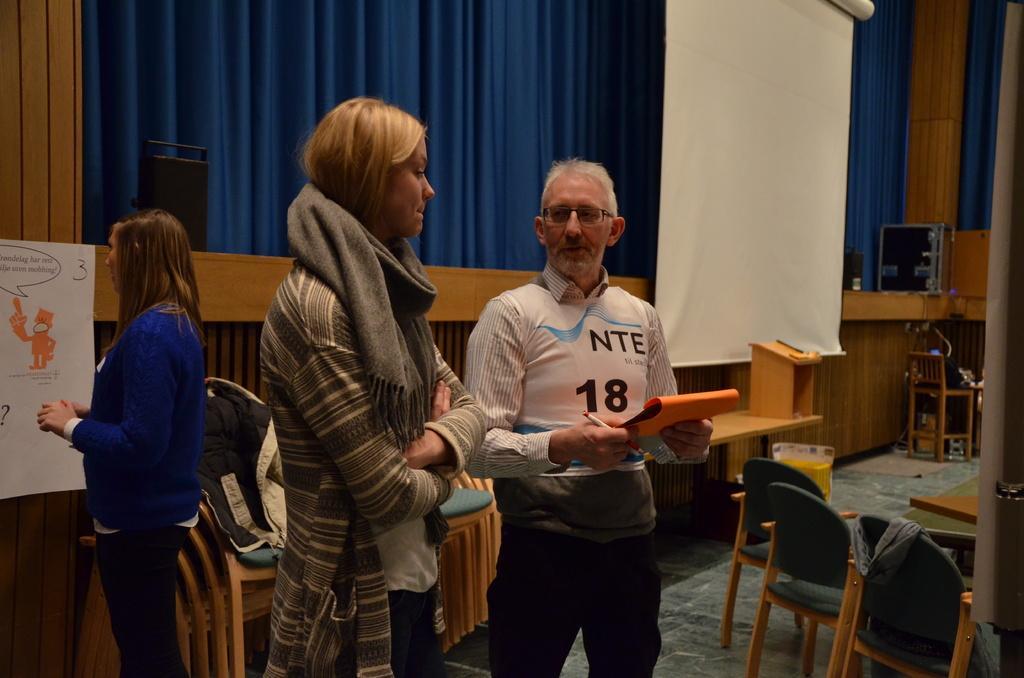Could you give a brief overview of what you see in this image? In picture there are two women and man a man and women are talking to each other in the room there are many chairs with the tables there is a curtain on the wall there are sound boxes there is a jacket on the chair there is a chart on the wall. 